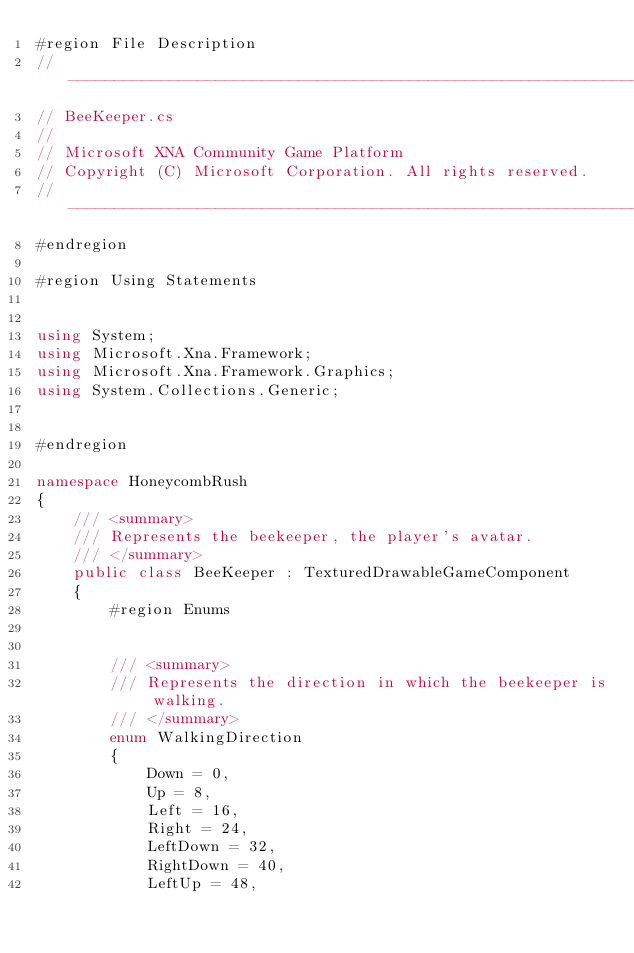Convert code to text. <code><loc_0><loc_0><loc_500><loc_500><_C#_>#region File Description
//-----------------------------------------------------------------------------
// BeeKeeper.cs
//
// Microsoft XNA Community Game Platform
// Copyright (C) Microsoft Corporation. All rights reserved.
//-----------------------------------------------------------------------------
#endregion

#region Using Statements


using System;
using Microsoft.Xna.Framework;
using Microsoft.Xna.Framework.Graphics;
using System.Collections.Generic;


#endregion

namespace HoneycombRush
{
    /// <summary>
    /// Represents the beekeeper, the player's avatar.
    /// </summary>
    public class BeeKeeper : TexturedDrawableGameComponent
    {
        #region Enums


        /// <summary>
        /// Represents the direction in which the beekeeper is walking.
        /// </summary>
        enum WalkingDirection
        {
            Down = 0,
            Up = 8,
            Left = 16,
            Right = 24,
            LeftDown = 32,
            RightDown = 40,
            LeftUp = 48,</code> 